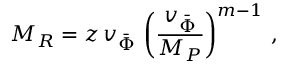Convert formula to latex. <formula><loc_0><loc_0><loc_500><loc_500>M _ { R } = z \, v _ { \bar { \Phi } } \, \left ( \frac { v _ { \bar { \Phi } } } { M _ { P } } \right ) ^ { m - 1 } \, ,</formula> 